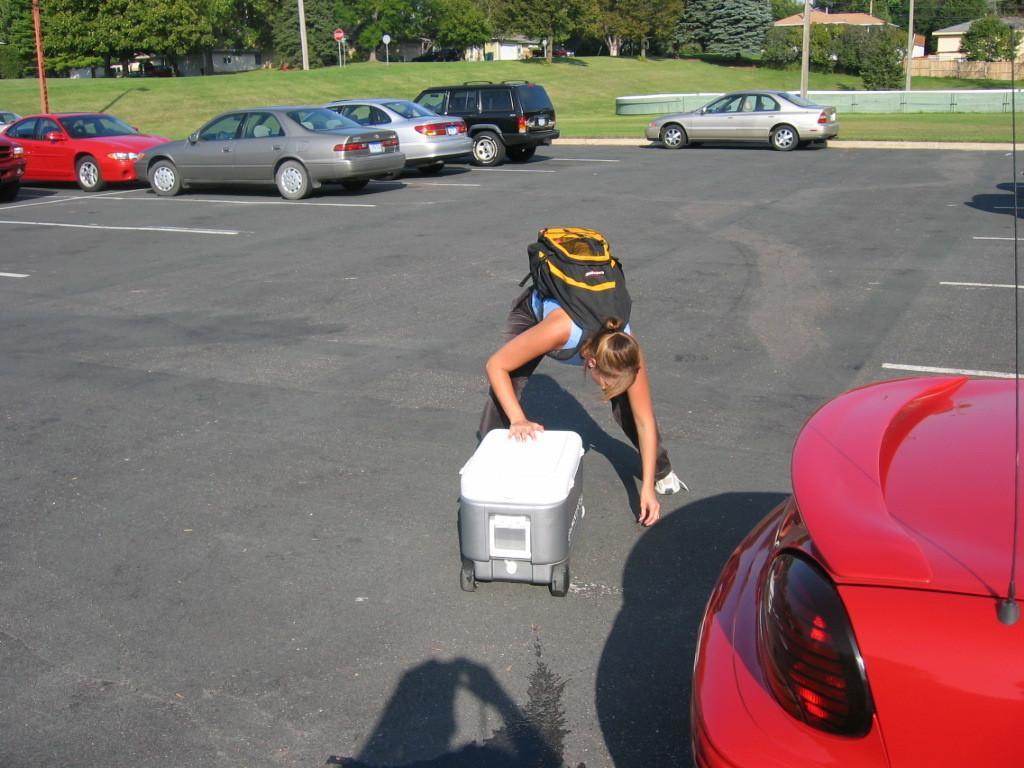Could you give a brief overview of what you see in this image? In this image I see the road on which there are cars and I see a woman over here who is wearing a bag and I see a white color container over here. In the background I see the green grass, poles, trees and the buildings. 